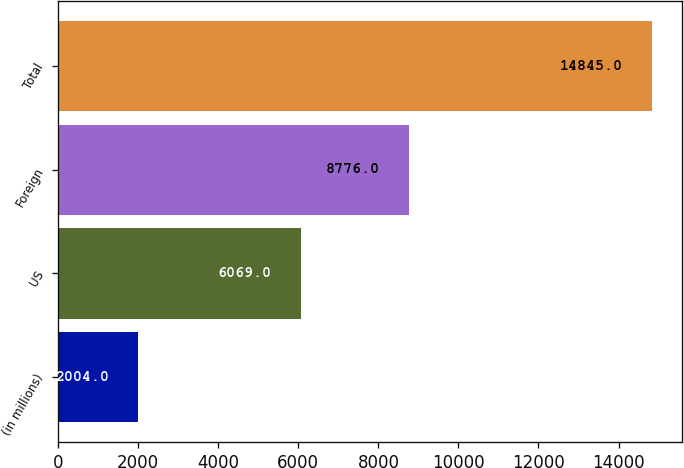Convert chart to OTSL. <chart><loc_0><loc_0><loc_500><loc_500><bar_chart><fcel>(in millions)<fcel>US<fcel>Foreign<fcel>Total<nl><fcel>2004<fcel>6069<fcel>8776<fcel>14845<nl></chart> 